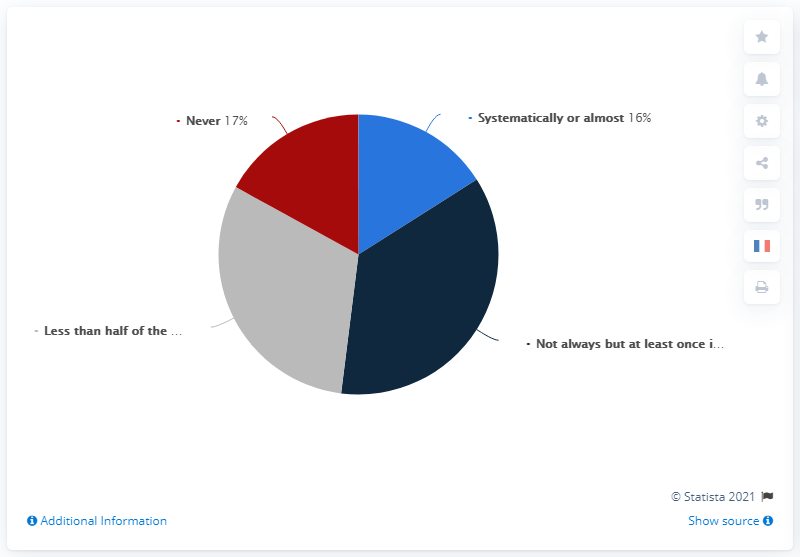Point out several critical features in this image. Grey indicates that less than half of the time. 